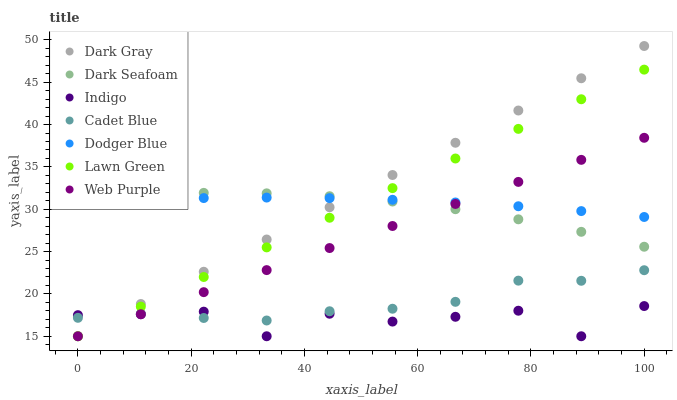Does Indigo have the minimum area under the curve?
Answer yes or no. Yes. Does Dark Gray have the maximum area under the curve?
Answer yes or no. Yes. Does Cadet Blue have the minimum area under the curve?
Answer yes or no. No. Does Cadet Blue have the maximum area under the curve?
Answer yes or no. No. Is Dark Gray the smoothest?
Answer yes or no. Yes. Is Indigo the roughest?
Answer yes or no. Yes. Is Cadet Blue the smoothest?
Answer yes or no. No. Is Cadet Blue the roughest?
Answer yes or no. No. Does Lawn Green have the lowest value?
Answer yes or no. Yes. Does Cadet Blue have the lowest value?
Answer yes or no. No. Does Dark Gray have the highest value?
Answer yes or no. Yes. Does Cadet Blue have the highest value?
Answer yes or no. No. Is Cadet Blue less than Dark Seafoam?
Answer yes or no. Yes. Is Dodger Blue greater than Cadet Blue?
Answer yes or no. Yes. Does Dodger Blue intersect Dark Seafoam?
Answer yes or no. Yes. Is Dodger Blue less than Dark Seafoam?
Answer yes or no. No. Is Dodger Blue greater than Dark Seafoam?
Answer yes or no. No. Does Cadet Blue intersect Dark Seafoam?
Answer yes or no. No. 